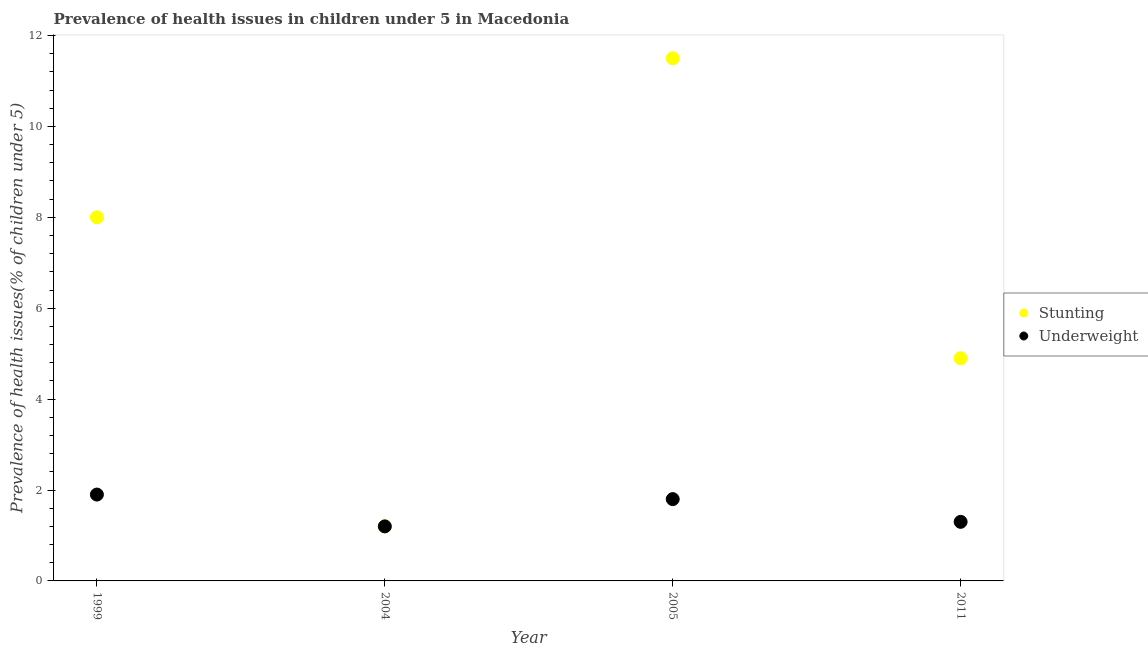Is the number of dotlines equal to the number of legend labels?
Your answer should be compact. Yes. What is the percentage of underweight children in 2011?
Provide a succinct answer. 1.3. In which year was the percentage of stunted children minimum?
Make the answer very short. 2004. What is the total percentage of underweight children in the graph?
Offer a very short reply. 6.2. What is the difference between the percentage of stunted children in 1999 and that in 2011?
Give a very brief answer. 3.1. What is the average percentage of underweight children per year?
Your answer should be compact. 1.55. In the year 1999, what is the difference between the percentage of underweight children and percentage of stunted children?
Give a very brief answer. -6.1. In how many years, is the percentage of underweight children greater than 9.2 %?
Your answer should be very brief. 0. What is the ratio of the percentage of stunted children in 2005 to that in 2011?
Your response must be concise. 2.35. What is the difference between the highest and the second highest percentage of underweight children?
Your answer should be compact. 0.1. What is the difference between the highest and the lowest percentage of underweight children?
Your answer should be very brief. 0.7. Does the percentage of underweight children monotonically increase over the years?
Keep it short and to the point. No. Is the percentage of stunted children strictly greater than the percentage of underweight children over the years?
Your response must be concise. No. How many dotlines are there?
Your response must be concise. 2. What is the difference between two consecutive major ticks on the Y-axis?
Ensure brevity in your answer.  2. Does the graph contain grids?
Keep it short and to the point. No. What is the title of the graph?
Keep it short and to the point. Prevalence of health issues in children under 5 in Macedonia. What is the label or title of the Y-axis?
Keep it short and to the point. Prevalence of health issues(% of children under 5). What is the Prevalence of health issues(% of children under 5) in Stunting in 1999?
Provide a short and direct response. 8. What is the Prevalence of health issues(% of children under 5) in Underweight in 1999?
Provide a succinct answer. 1.9. What is the Prevalence of health issues(% of children under 5) in Stunting in 2004?
Offer a very short reply. 1.2. What is the Prevalence of health issues(% of children under 5) of Underweight in 2005?
Give a very brief answer. 1.8. What is the Prevalence of health issues(% of children under 5) in Stunting in 2011?
Your answer should be very brief. 4.9. What is the Prevalence of health issues(% of children under 5) in Underweight in 2011?
Make the answer very short. 1.3. Across all years, what is the maximum Prevalence of health issues(% of children under 5) in Stunting?
Make the answer very short. 11.5. Across all years, what is the maximum Prevalence of health issues(% of children under 5) in Underweight?
Provide a short and direct response. 1.9. Across all years, what is the minimum Prevalence of health issues(% of children under 5) of Underweight?
Offer a very short reply. 1.2. What is the total Prevalence of health issues(% of children under 5) in Stunting in the graph?
Ensure brevity in your answer.  25.6. What is the total Prevalence of health issues(% of children under 5) of Underweight in the graph?
Provide a short and direct response. 6.2. What is the difference between the Prevalence of health issues(% of children under 5) in Stunting in 1999 and that in 2004?
Offer a very short reply. 6.8. What is the difference between the Prevalence of health issues(% of children under 5) of Stunting in 1999 and that in 2005?
Your response must be concise. -3.5. What is the difference between the Prevalence of health issues(% of children under 5) of Underweight in 1999 and that in 2005?
Ensure brevity in your answer.  0.1. What is the difference between the Prevalence of health issues(% of children under 5) of Stunting in 1999 and that in 2011?
Provide a succinct answer. 3.1. What is the difference between the Prevalence of health issues(% of children under 5) of Underweight in 1999 and that in 2011?
Your answer should be compact. 0.6. What is the difference between the Prevalence of health issues(% of children under 5) of Underweight in 2004 and that in 2005?
Offer a terse response. -0.6. What is the difference between the Prevalence of health issues(% of children under 5) in Stunting in 2004 and that in 2011?
Ensure brevity in your answer.  -3.7. What is the difference between the Prevalence of health issues(% of children under 5) in Underweight in 2004 and that in 2011?
Give a very brief answer. -0.1. What is the difference between the Prevalence of health issues(% of children under 5) of Underweight in 2005 and that in 2011?
Offer a very short reply. 0.5. What is the difference between the Prevalence of health issues(% of children under 5) of Stunting in 1999 and the Prevalence of health issues(% of children under 5) of Underweight in 2005?
Provide a succinct answer. 6.2. What is the difference between the Prevalence of health issues(% of children under 5) in Stunting in 2005 and the Prevalence of health issues(% of children under 5) in Underweight in 2011?
Keep it short and to the point. 10.2. What is the average Prevalence of health issues(% of children under 5) of Underweight per year?
Offer a very short reply. 1.55. In the year 2011, what is the difference between the Prevalence of health issues(% of children under 5) of Stunting and Prevalence of health issues(% of children under 5) of Underweight?
Ensure brevity in your answer.  3.6. What is the ratio of the Prevalence of health issues(% of children under 5) of Underweight in 1999 to that in 2004?
Provide a short and direct response. 1.58. What is the ratio of the Prevalence of health issues(% of children under 5) of Stunting in 1999 to that in 2005?
Ensure brevity in your answer.  0.7. What is the ratio of the Prevalence of health issues(% of children under 5) of Underweight in 1999 to that in 2005?
Keep it short and to the point. 1.06. What is the ratio of the Prevalence of health issues(% of children under 5) in Stunting in 1999 to that in 2011?
Give a very brief answer. 1.63. What is the ratio of the Prevalence of health issues(% of children under 5) in Underweight in 1999 to that in 2011?
Your response must be concise. 1.46. What is the ratio of the Prevalence of health issues(% of children under 5) of Stunting in 2004 to that in 2005?
Keep it short and to the point. 0.1. What is the ratio of the Prevalence of health issues(% of children under 5) in Stunting in 2004 to that in 2011?
Ensure brevity in your answer.  0.24. What is the ratio of the Prevalence of health issues(% of children under 5) in Stunting in 2005 to that in 2011?
Your answer should be very brief. 2.35. What is the ratio of the Prevalence of health issues(% of children under 5) of Underweight in 2005 to that in 2011?
Your answer should be compact. 1.38. What is the difference between the highest and the second highest Prevalence of health issues(% of children under 5) of Underweight?
Keep it short and to the point. 0.1. What is the difference between the highest and the lowest Prevalence of health issues(% of children under 5) in Underweight?
Your answer should be compact. 0.7. 